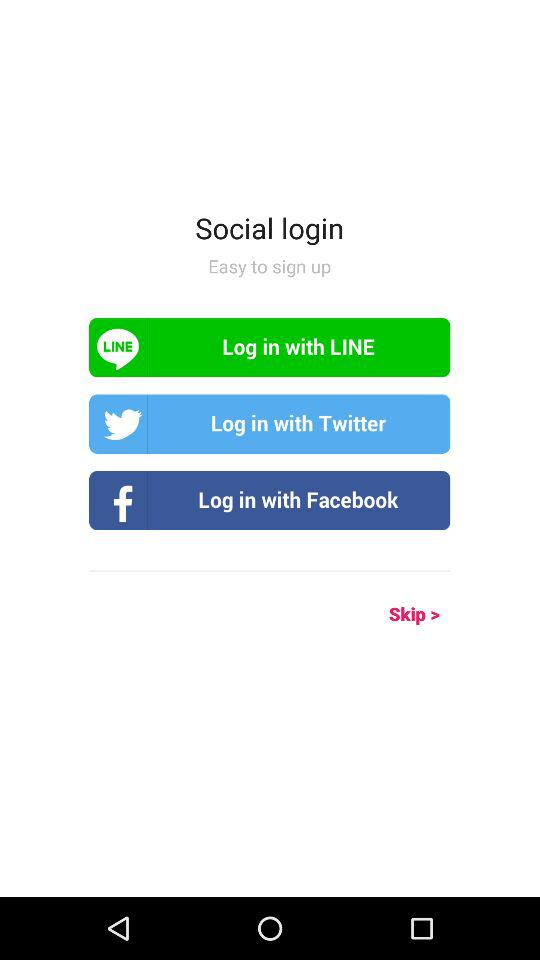Through which applications can we log in? You can log in through "LINE", "Twitter" and "Facebook". 